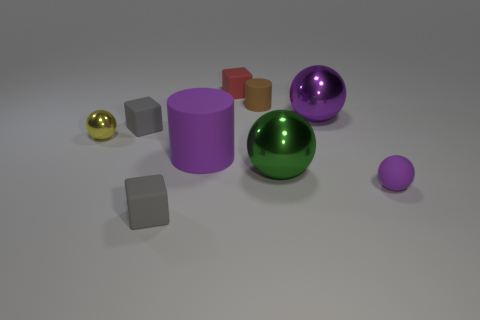Subtract 1 spheres. How many spheres are left? 3 Add 1 shiny spheres. How many objects exist? 10 Subtract all balls. How many objects are left? 5 Add 3 red rubber objects. How many red rubber objects are left? 4 Add 5 purple things. How many purple things exist? 8 Subtract 1 yellow balls. How many objects are left? 8 Subtract all big green shiny balls. Subtract all green shiny spheres. How many objects are left? 7 